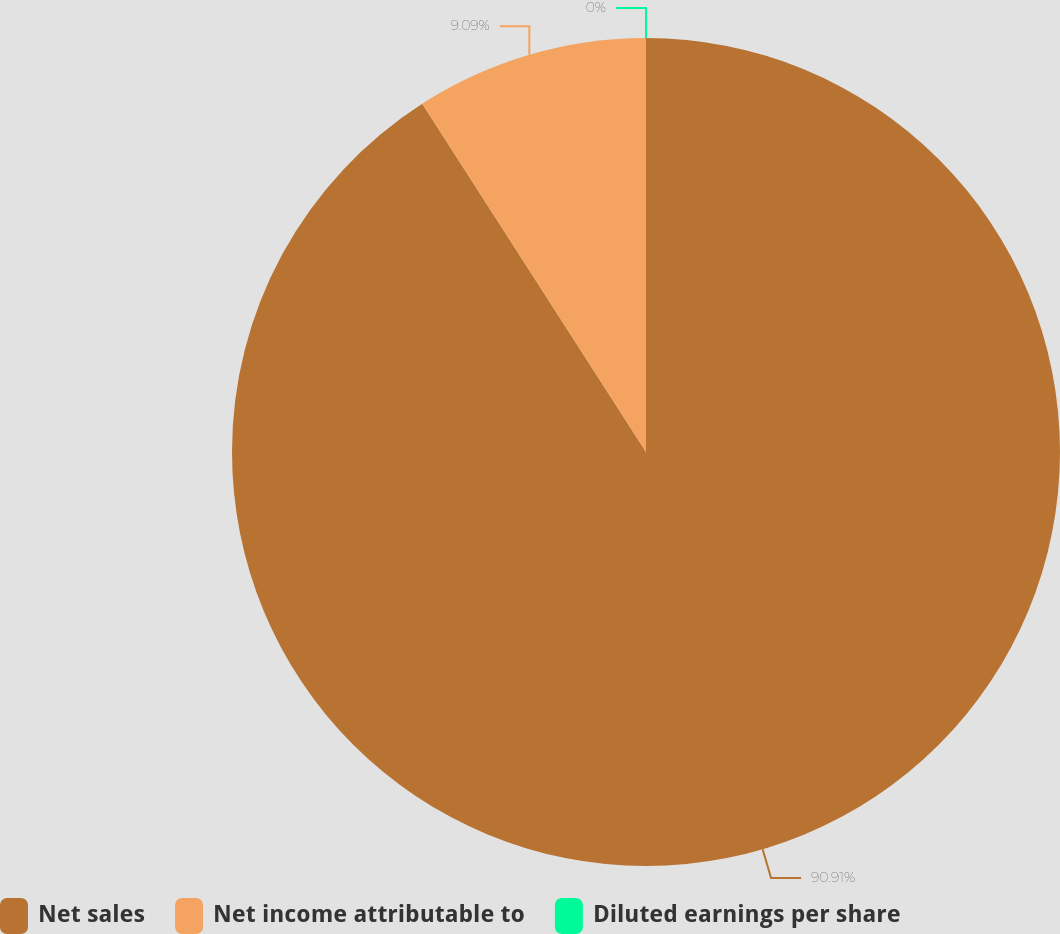Convert chart. <chart><loc_0><loc_0><loc_500><loc_500><pie_chart><fcel>Net sales<fcel>Net income attributable to<fcel>Diluted earnings per share<nl><fcel>90.91%<fcel>9.09%<fcel>0.0%<nl></chart> 